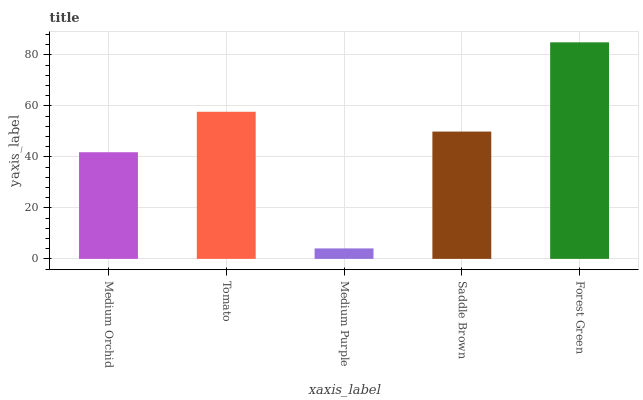Is Medium Purple the minimum?
Answer yes or no. Yes. Is Forest Green the maximum?
Answer yes or no. Yes. Is Tomato the minimum?
Answer yes or no. No. Is Tomato the maximum?
Answer yes or no. No. Is Tomato greater than Medium Orchid?
Answer yes or no. Yes. Is Medium Orchid less than Tomato?
Answer yes or no. Yes. Is Medium Orchid greater than Tomato?
Answer yes or no. No. Is Tomato less than Medium Orchid?
Answer yes or no. No. Is Saddle Brown the high median?
Answer yes or no. Yes. Is Saddle Brown the low median?
Answer yes or no. Yes. Is Medium Orchid the high median?
Answer yes or no. No. Is Medium Purple the low median?
Answer yes or no. No. 